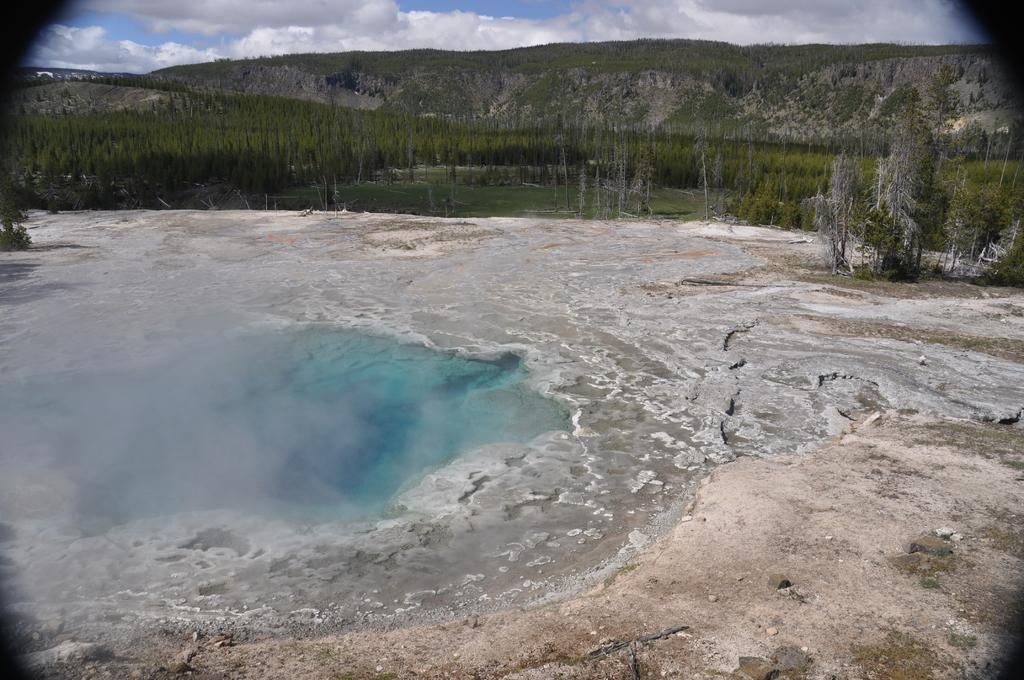How has the image been altered or modified? The image is edited. What natural feature is the main subject of the image? There is a hot spring in the image. What type of vegetation can be seen in the background of the image? There are trees in the background of the image. What geographical features are visible in the background of the image? There are mountains in the background of the image. What part of the natural environment is visible in the background of the image? The sky is visible in the background of the image. Can you see a dog playing near the hot spring in the image? There is no dog present in the image; it features a hot spring, trees, mountains, and the sky. 